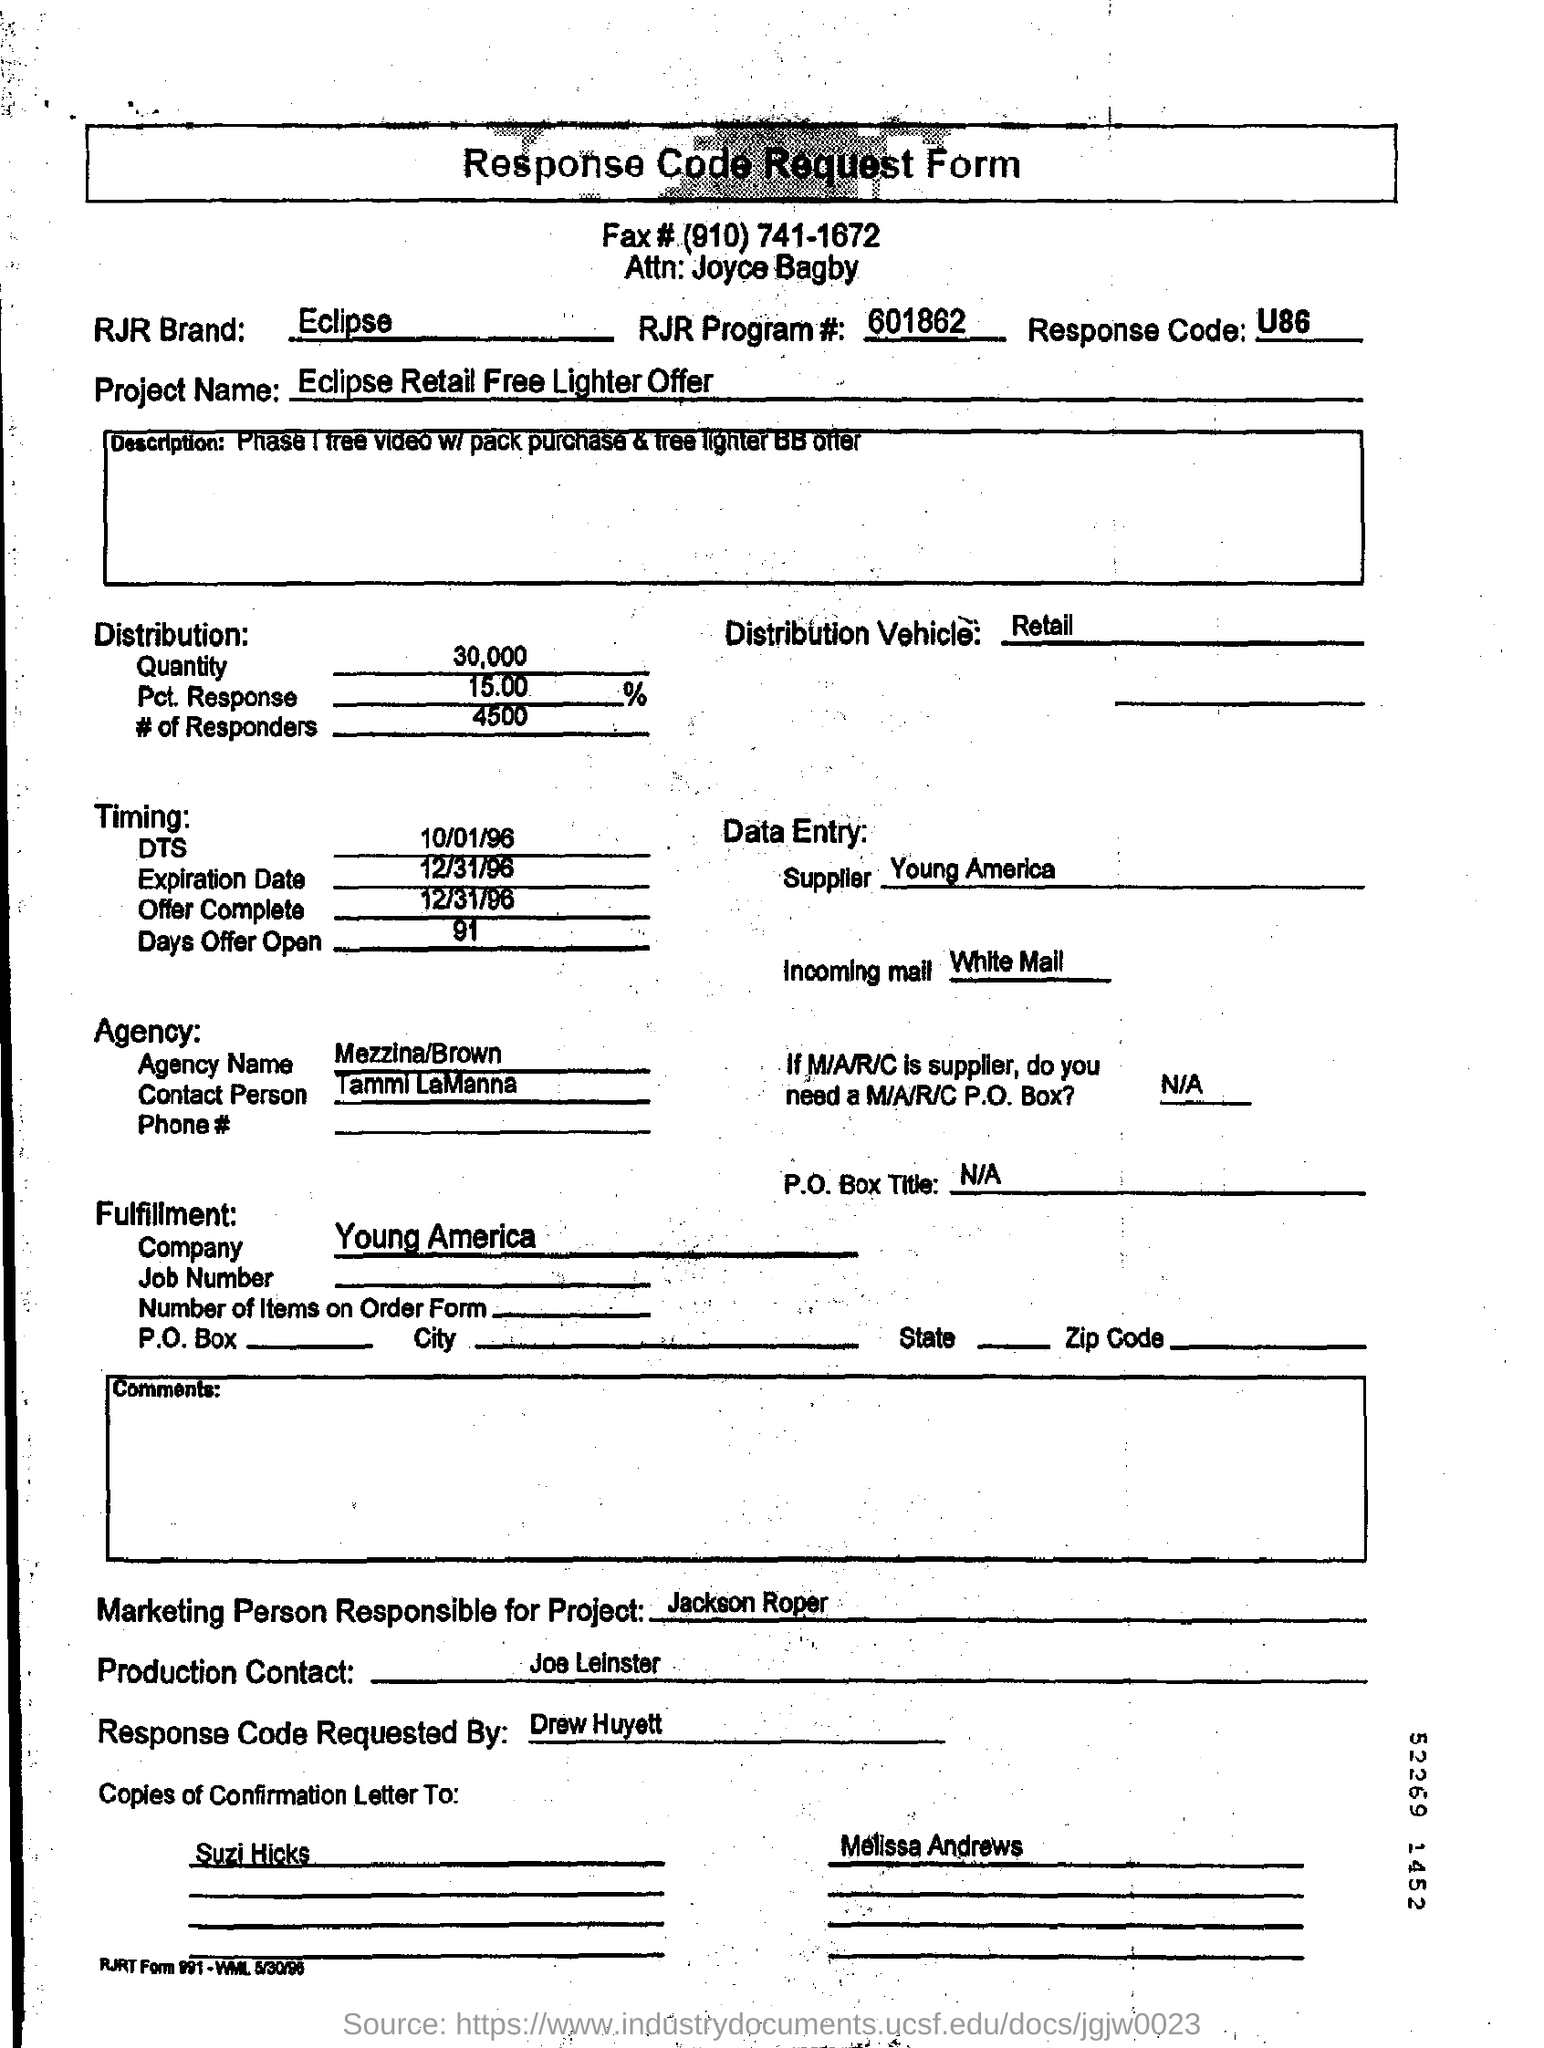What is the RJR Brand?
Provide a short and direct response. Eclipse. What is the RJR Program #?
Provide a succinct answer. 601862. What is the Response code?
Provide a short and direct response. U86. What is the Quantity?
Keep it short and to the point. 30,000. What is the Pct. Response?
Keep it short and to the point. 15.00. What are the # of Responders?
Your response must be concise. 4500. What is the distribution vehicle?
Provide a short and direct response. Retail. Who is the Supplier?
Provide a short and direct response. Young America. What is the DTS?
Your answer should be compact. 10/01/96. What is the expiration date?
Offer a terse response. 12/31/96. What is the Days offer open?
Your answer should be very brief. 91. 